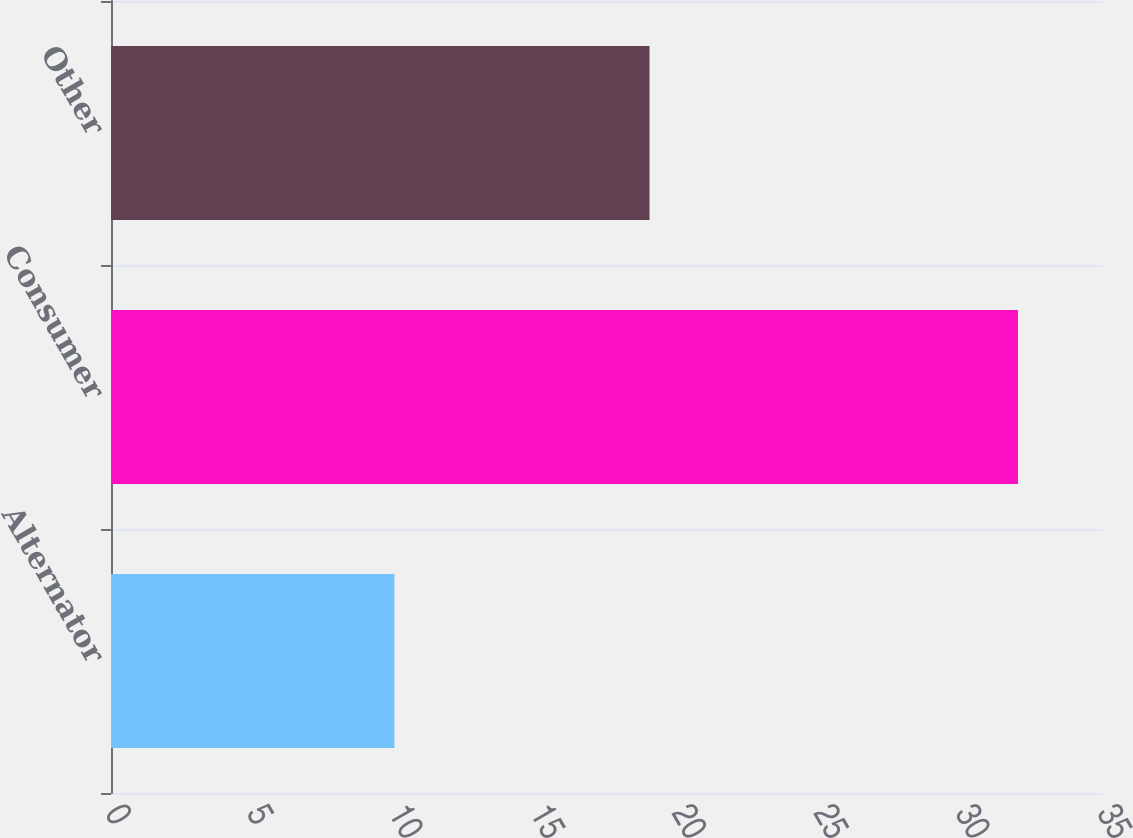Convert chart. <chart><loc_0><loc_0><loc_500><loc_500><bar_chart><fcel>Alternator<fcel>Consumer<fcel>Other<nl><fcel>10<fcel>32<fcel>19<nl></chart> 